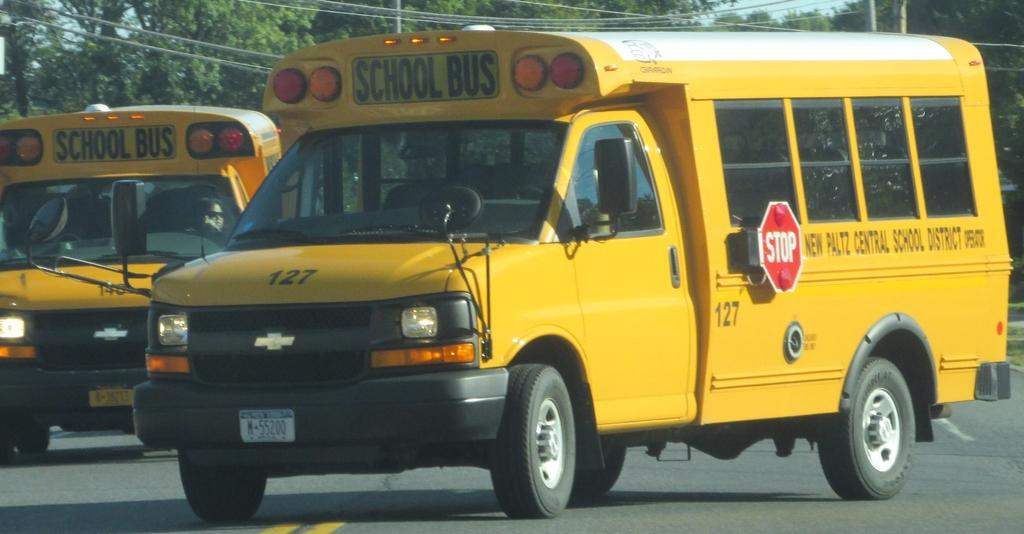<image>
Write a terse but informative summary of the picture. A yellow school bus #127 from New Platz Central School District is shown on the road. 